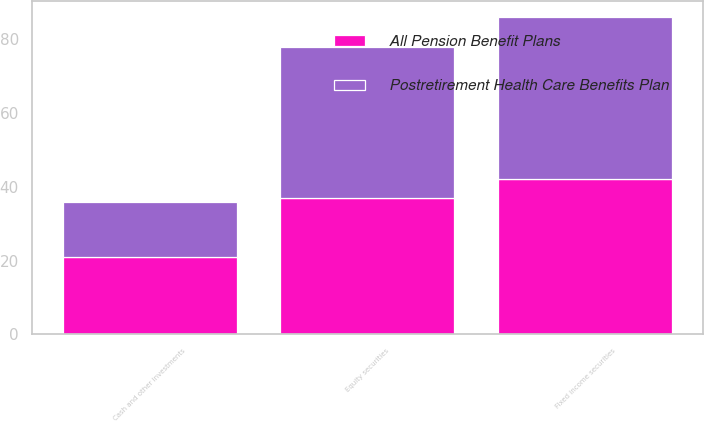Convert chart. <chart><loc_0><loc_0><loc_500><loc_500><stacked_bar_chart><ecel><fcel>Equity securities<fcel>Fixed income securities<fcel>Cash and other investments<nl><fcel>Postretirement Health Care Benefits Plan<fcel>41<fcel>44<fcel>15<nl><fcel>All Pension Benefit Plans<fcel>37<fcel>42<fcel>21<nl></chart> 